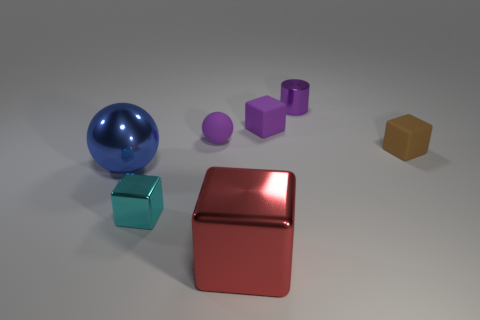How many objects are tiny metal objects in front of the metal sphere or metal objects that are behind the tiny cyan shiny block?
Your answer should be very brief. 3. There is a tiny rubber thing behind the purple ball; what is its color?
Your answer should be compact. Purple. There is a large blue metallic object in front of the purple matte block; are there any purple objects left of it?
Give a very brief answer. No. Are there fewer tiny objects than cubes?
Keep it short and to the point. No. The block that is behind the ball that is behind the brown object is made of what material?
Provide a succinct answer. Rubber. Does the purple cylinder have the same size as the red block?
Ensure brevity in your answer.  No. How many objects are cylinders or large cylinders?
Provide a short and direct response. 1. How big is the rubber object that is both to the left of the purple shiny cylinder and to the right of the matte sphere?
Your response must be concise. Small. Is the number of purple cylinders that are to the right of the small brown matte block less than the number of small matte things?
Offer a terse response. Yes. What shape is the other large thing that is the same material as the big red thing?
Make the answer very short. Sphere. 